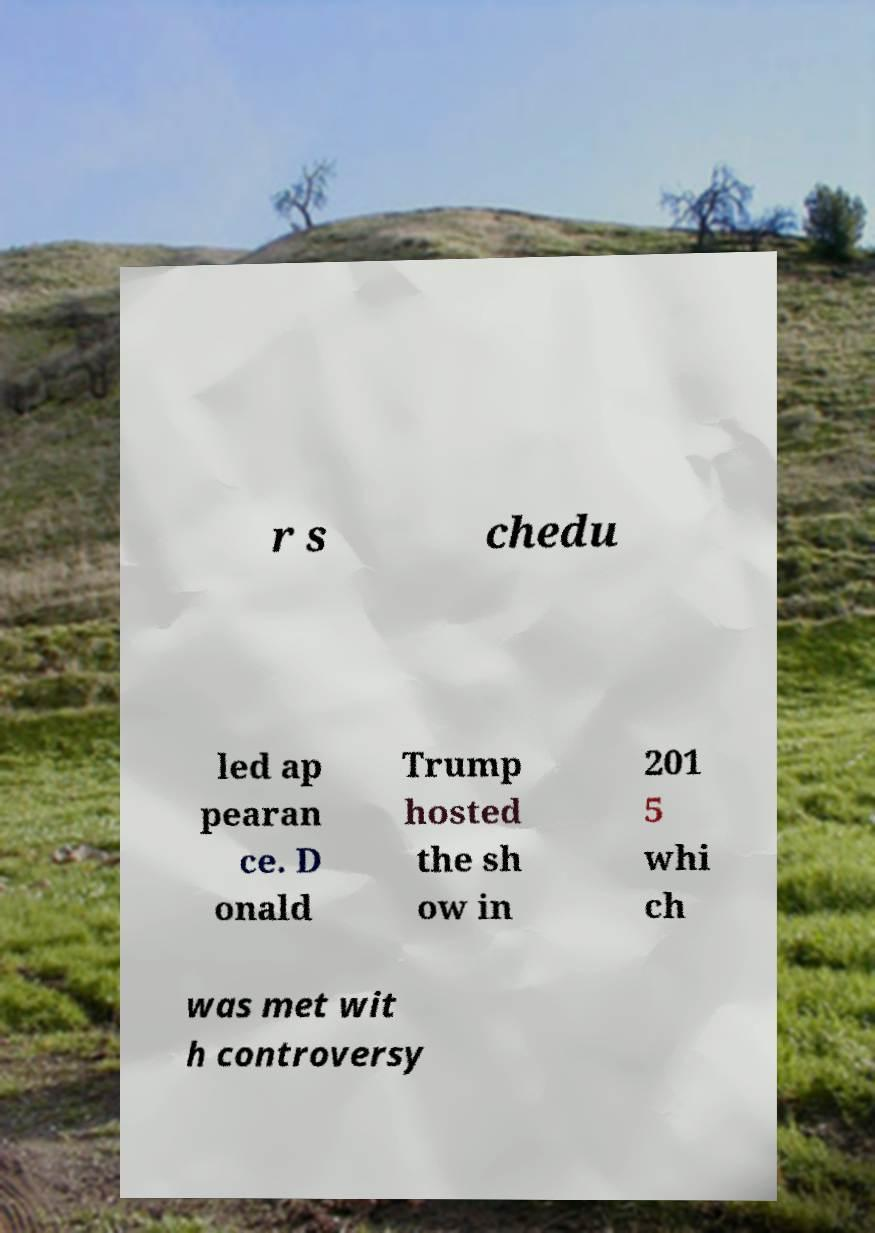Could you assist in decoding the text presented in this image and type it out clearly? r s chedu led ap pearan ce. D onald Trump hosted the sh ow in 201 5 whi ch was met wit h controversy 